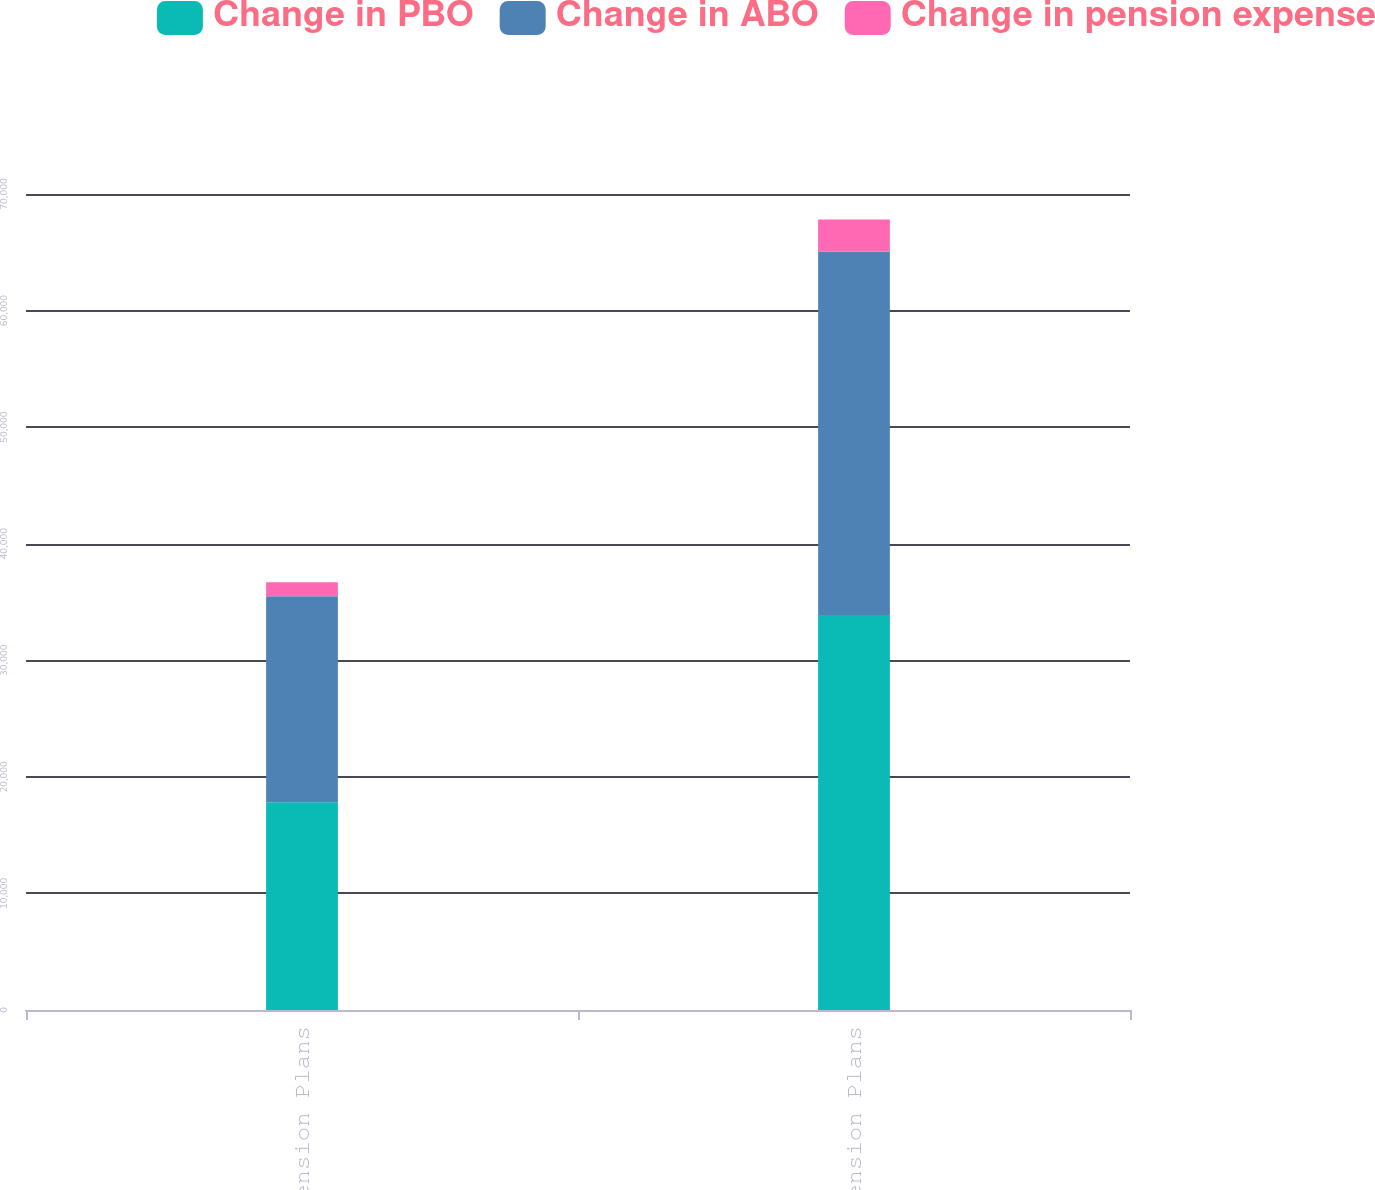<chart> <loc_0><loc_0><loc_500><loc_500><stacked_bar_chart><ecel><fcel>US Pension Plans<fcel>Non-US Pension Plans<nl><fcel>Change in PBO<fcel>17816<fcel>33889<nl><fcel>Change in ABO<fcel>17687<fcel>31185<nl><fcel>Change in pension expense<fcel>1181<fcel>2733<nl></chart> 